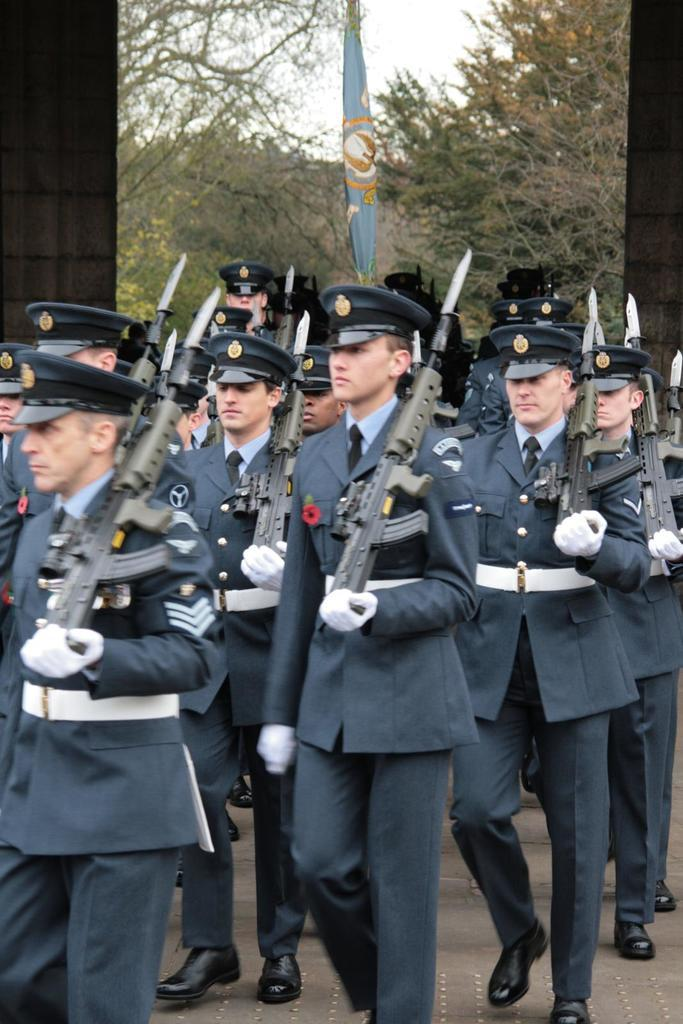How many people are in the image? There are people in the image, but the exact number is not specified. What are the people doing in the image? The people are walking and holding guns. What type of headgear are the people wearing? The people are wearing wire caps. What can be seen in the background of the image? There is a flag, trees, and the sky visible in the background of the image. What does the taste of the wire caps feel like in the image? There is no mention of the taste of the wire caps in the image, as they are a type of headgear and not a food item. 